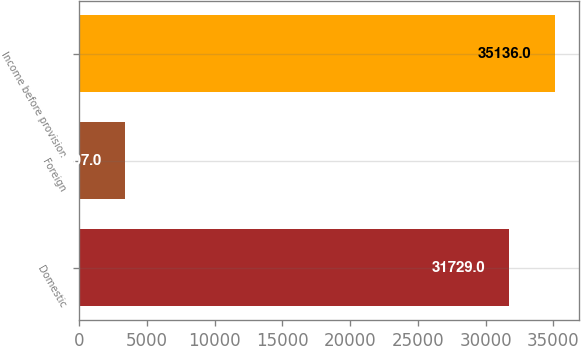Convert chart. <chart><loc_0><loc_0><loc_500><loc_500><bar_chart><fcel>Domestic<fcel>Foreign<fcel>Income before provision<nl><fcel>31729<fcel>3407<fcel>35136<nl></chart> 